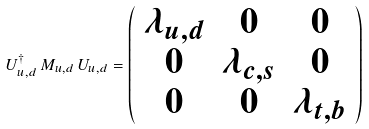<formula> <loc_0><loc_0><loc_500><loc_500>U ^ { \dagger } _ { u , d } \, M _ { u , d } \, U _ { u , d } = \left ( \begin{array} { c c c } \lambda _ { u , d } & 0 & 0 \\ 0 & \lambda _ { c , s } & 0 \\ 0 & 0 & \lambda _ { t , b } \end{array} \right )</formula> 